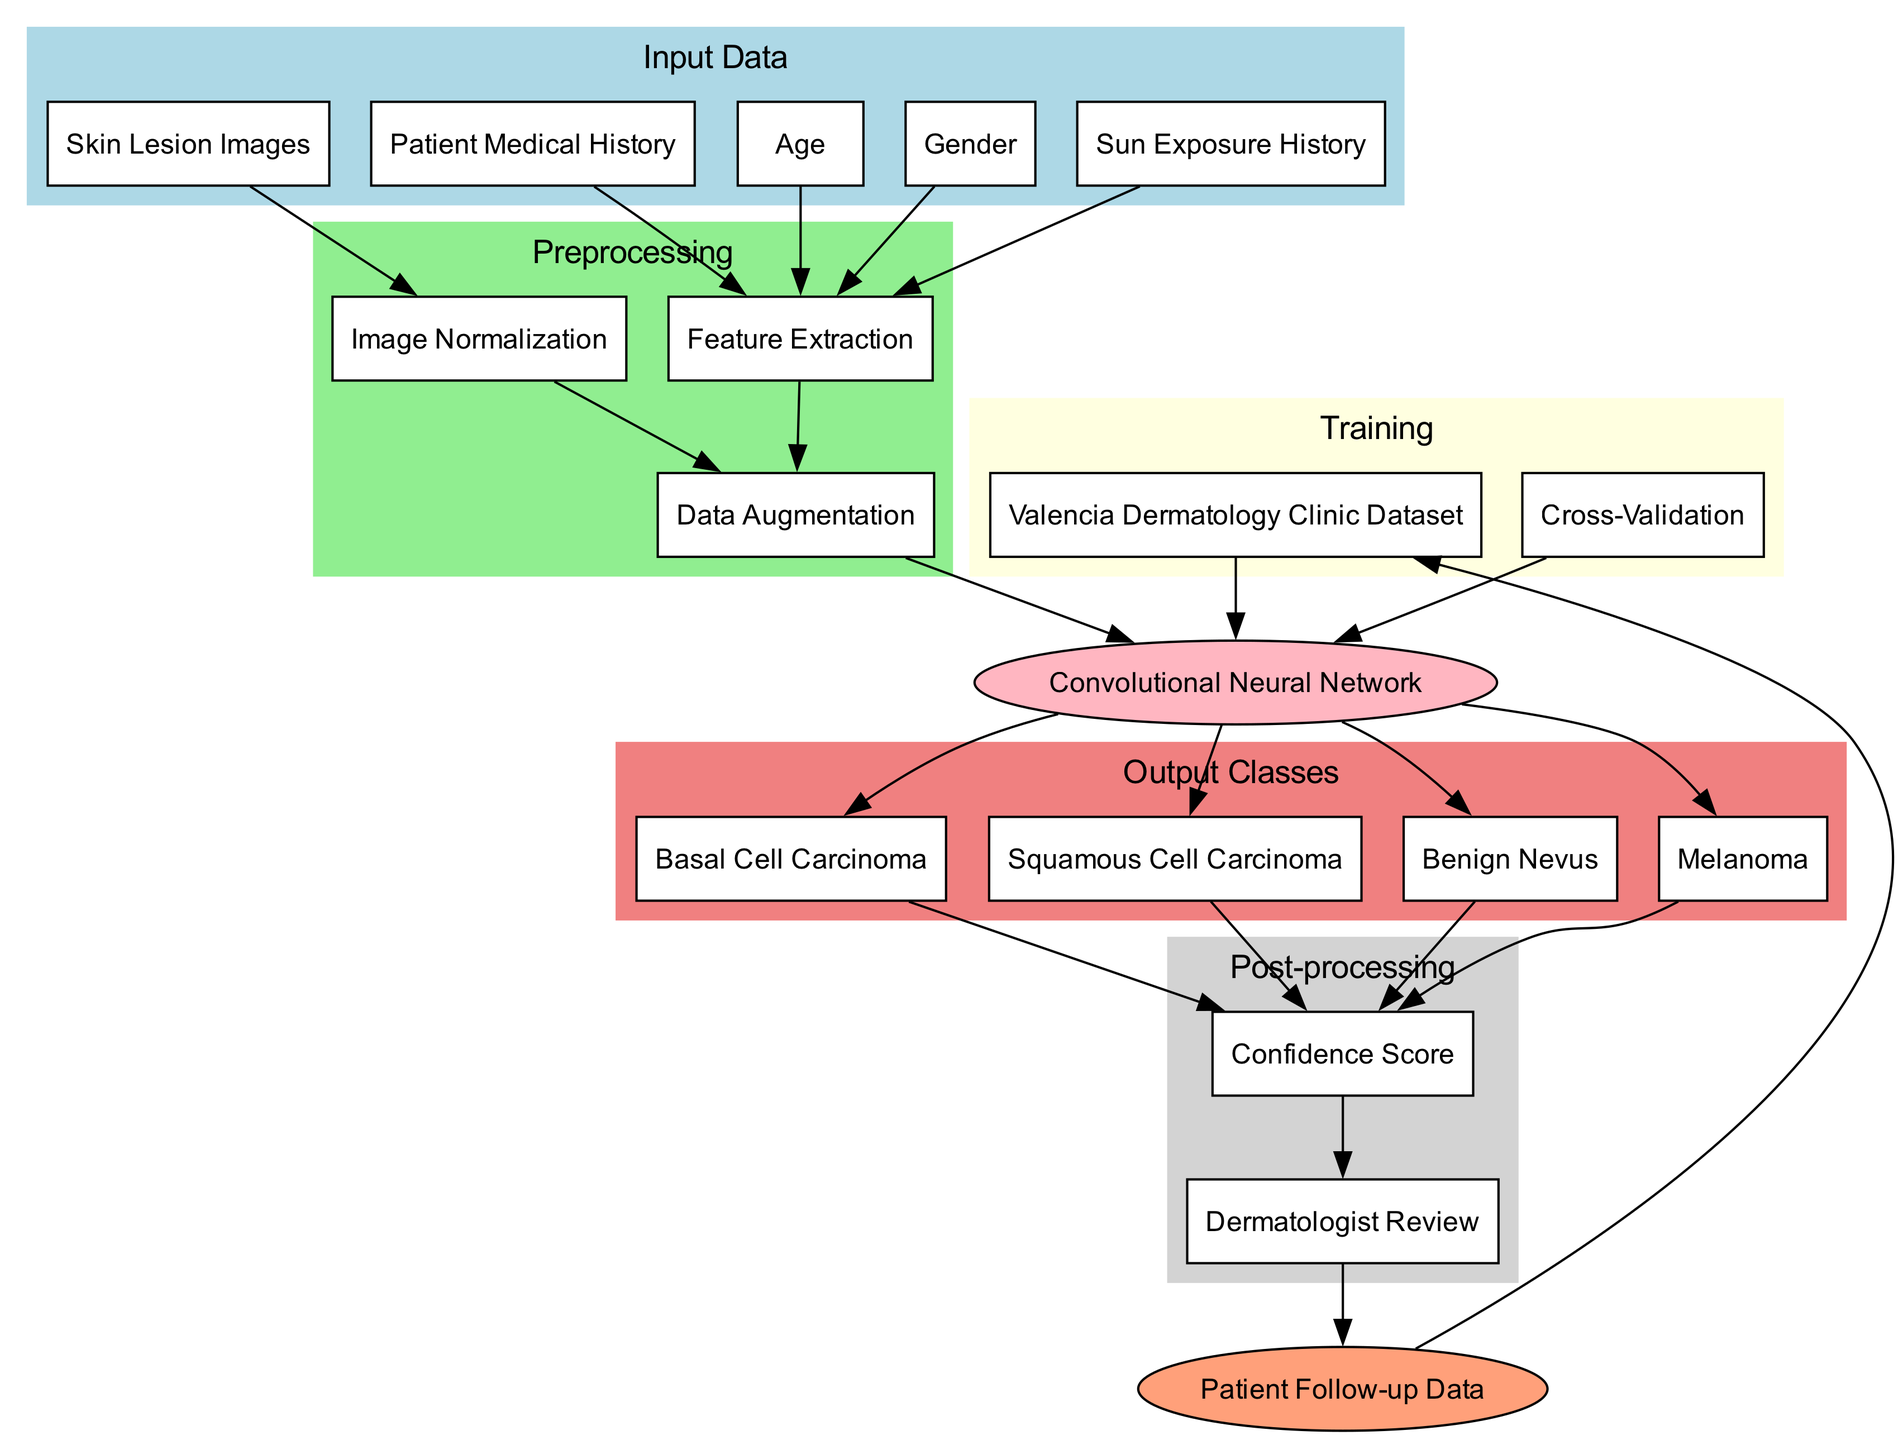What are the input data types for the machine learning model? The input data types are listed in the diagram under the "Input Data" section. They include Patient Medical History, Skin Lesion Images, Age, Gender, and Sun Exposure History.
Answer: Patient Medical History, Skin Lesion Images, Age, Gender, Sun Exposure History How many output classes does the model classify? The diagram lists four output classes under the "Output Classes" section: Melanoma, Basal Cell Carcinoma, Squamous Cell Carcinoma, and Benign Nevus. By counting these items, we determine there are four classes.
Answer: Four What is the main model used in the classification process? The model used is identified in the diagram as a Convolutional Neural Network, which is specifically noted in the "Model" section.
Answer: Convolutional Neural Network What preprocessing techniques are applied to the input data? The preprocessing techniques are shown under the "Preprocessing" section of the diagram. They include Image Normalization, Feature Extraction, and Data Augmentation.
Answer: Image Normalization, Feature Extraction, Data Augmentation Which node is directly linked to the Confidence Score? The diagram indicates that all output classes (Melanoma, Basal Cell Carcinoma, Squamous Cell Carcinoma, and Benign Nevus) are directly linked to the Confidence Score. Therefore, the answer is the output classes.
Answer: Melanoma, Basal Cell Carcinoma, Squamous Cell Carcinoma, Benign Nevus What feedback mechanism is illustrated in the diagram? The feedback loop is shown at the bottom of the diagram, indicating that Patient Follow-up Data is used as feedback into the system to improve the dataset.
Answer: Patient Follow-up Data What is the purpose of Cross-Validation in the training phase? Cross-Validation is a technique used in training to ensure the model performs well on unseen data. It is included in the "Training" section of the diagram and is crucial for evaluating the model's accuracy.
Answer: Evaluate model accuracy How does the process flow from images to the model? The flow starts with Skin Lesion Images going to Image Normalization, which then connects to Data Augmentation, leading to the model. This sequence indicates that images undergo normalization and augmentation before being input into the model.
Answer: Image Normalization to Data Augmentation to model What is the final step before the output is confirmed? The final step in the process after the model generates classifications is the Dermatologist Review, which is indicated in the post-processing section. This step serves to validate the model's predictions.
Answer: Dermatologist Review 